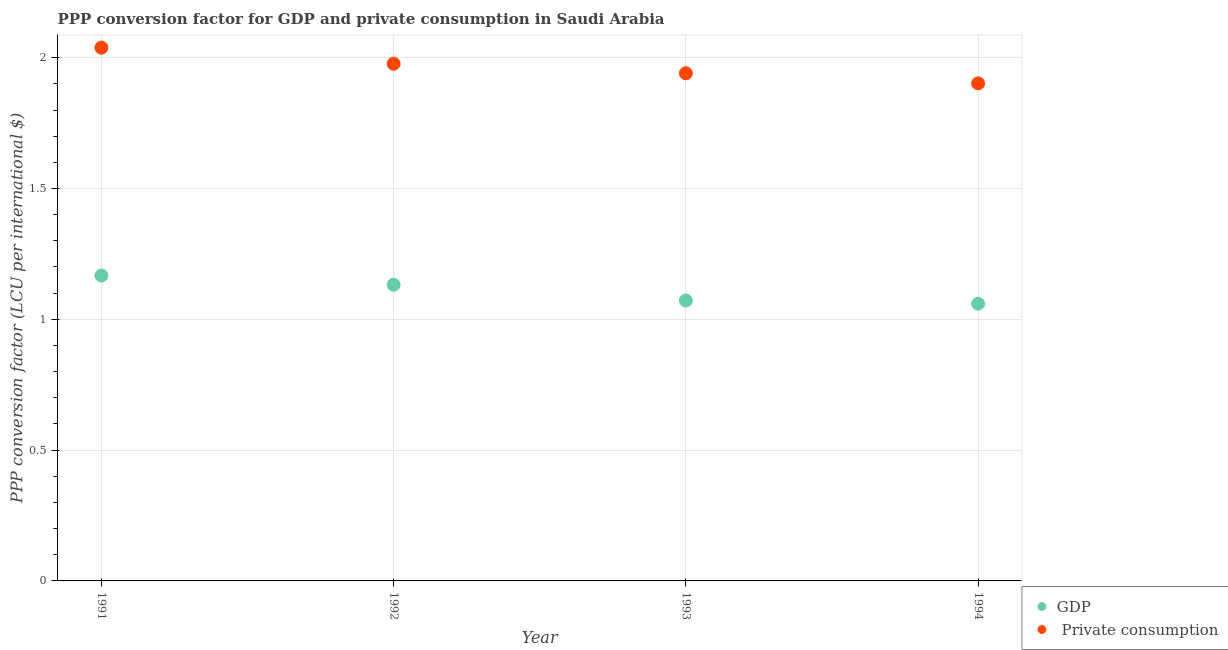What is the ppp conversion factor for gdp in 1993?
Provide a short and direct response. 1.07. Across all years, what is the maximum ppp conversion factor for gdp?
Give a very brief answer. 1.17. Across all years, what is the minimum ppp conversion factor for gdp?
Provide a succinct answer. 1.06. In which year was the ppp conversion factor for gdp maximum?
Ensure brevity in your answer.  1991. In which year was the ppp conversion factor for gdp minimum?
Your response must be concise. 1994. What is the total ppp conversion factor for private consumption in the graph?
Ensure brevity in your answer.  7.86. What is the difference between the ppp conversion factor for private consumption in 1991 and that in 1992?
Make the answer very short. 0.06. What is the difference between the ppp conversion factor for private consumption in 1993 and the ppp conversion factor for gdp in 1991?
Give a very brief answer. 0.77. What is the average ppp conversion factor for gdp per year?
Provide a short and direct response. 1.11. In the year 1994, what is the difference between the ppp conversion factor for gdp and ppp conversion factor for private consumption?
Your answer should be very brief. -0.84. In how many years, is the ppp conversion factor for gdp greater than 0.2 LCU?
Provide a succinct answer. 4. What is the ratio of the ppp conversion factor for private consumption in 1992 to that in 1994?
Make the answer very short. 1.04. What is the difference between the highest and the second highest ppp conversion factor for private consumption?
Give a very brief answer. 0.06. What is the difference between the highest and the lowest ppp conversion factor for private consumption?
Your answer should be very brief. 0.14. Is the sum of the ppp conversion factor for gdp in 1993 and 1994 greater than the maximum ppp conversion factor for private consumption across all years?
Your answer should be very brief. Yes. Does the ppp conversion factor for private consumption monotonically increase over the years?
Offer a very short reply. No. How many dotlines are there?
Your response must be concise. 2. What is the difference between two consecutive major ticks on the Y-axis?
Your answer should be very brief. 0.5. Are the values on the major ticks of Y-axis written in scientific E-notation?
Offer a terse response. No. Does the graph contain any zero values?
Your response must be concise. No. Where does the legend appear in the graph?
Keep it short and to the point. Bottom right. How are the legend labels stacked?
Ensure brevity in your answer.  Vertical. What is the title of the graph?
Provide a succinct answer. PPP conversion factor for GDP and private consumption in Saudi Arabia. Does "Frequency of shipment arrival" appear as one of the legend labels in the graph?
Offer a terse response. No. What is the label or title of the X-axis?
Ensure brevity in your answer.  Year. What is the label or title of the Y-axis?
Provide a short and direct response. PPP conversion factor (LCU per international $). What is the PPP conversion factor (LCU per international $) in GDP in 1991?
Provide a succinct answer. 1.17. What is the PPP conversion factor (LCU per international $) in  Private consumption in 1991?
Provide a short and direct response. 2.04. What is the PPP conversion factor (LCU per international $) of GDP in 1992?
Provide a short and direct response. 1.13. What is the PPP conversion factor (LCU per international $) in  Private consumption in 1992?
Provide a succinct answer. 1.98. What is the PPP conversion factor (LCU per international $) in GDP in 1993?
Your answer should be very brief. 1.07. What is the PPP conversion factor (LCU per international $) in  Private consumption in 1993?
Your answer should be very brief. 1.94. What is the PPP conversion factor (LCU per international $) of GDP in 1994?
Your response must be concise. 1.06. What is the PPP conversion factor (LCU per international $) of  Private consumption in 1994?
Provide a short and direct response. 1.9. Across all years, what is the maximum PPP conversion factor (LCU per international $) in GDP?
Your answer should be compact. 1.17. Across all years, what is the maximum PPP conversion factor (LCU per international $) of  Private consumption?
Your response must be concise. 2.04. Across all years, what is the minimum PPP conversion factor (LCU per international $) of GDP?
Provide a succinct answer. 1.06. Across all years, what is the minimum PPP conversion factor (LCU per international $) in  Private consumption?
Give a very brief answer. 1.9. What is the total PPP conversion factor (LCU per international $) in GDP in the graph?
Offer a terse response. 4.43. What is the total PPP conversion factor (LCU per international $) in  Private consumption in the graph?
Give a very brief answer. 7.86. What is the difference between the PPP conversion factor (LCU per international $) in GDP in 1991 and that in 1992?
Make the answer very short. 0.04. What is the difference between the PPP conversion factor (LCU per international $) of  Private consumption in 1991 and that in 1992?
Offer a very short reply. 0.06. What is the difference between the PPP conversion factor (LCU per international $) of GDP in 1991 and that in 1993?
Your response must be concise. 0.1. What is the difference between the PPP conversion factor (LCU per international $) in  Private consumption in 1991 and that in 1993?
Your answer should be compact. 0.1. What is the difference between the PPP conversion factor (LCU per international $) in GDP in 1991 and that in 1994?
Your answer should be compact. 0.11. What is the difference between the PPP conversion factor (LCU per international $) in  Private consumption in 1991 and that in 1994?
Provide a succinct answer. 0.14. What is the difference between the PPP conversion factor (LCU per international $) of GDP in 1992 and that in 1993?
Your answer should be compact. 0.06. What is the difference between the PPP conversion factor (LCU per international $) of  Private consumption in 1992 and that in 1993?
Provide a succinct answer. 0.04. What is the difference between the PPP conversion factor (LCU per international $) of GDP in 1992 and that in 1994?
Your answer should be compact. 0.07. What is the difference between the PPP conversion factor (LCU per international $) in  Private consumption in 1992 and that in 1994?
Your answer should be very brief. 0.07. What is the difference between the PPP conversion factor (LCU per international $) of GDP in 1993 and that in 1994?
Your answer should be compact. 0.01. What is the difference between the PPP conversion factor (LCU per international $) of  Private consumption in 1993 and that in 1994?
Your answer should be compact. 0.04. What is the difference between the PPP conversion factor (LCU per international $) in GDP in 1991 and the PPP conversion factor (LCU per international $) in  Private consumption in 1992?
Your response must be concise. -0.81. What is the difference between the PPP conversion factor (LCU per international $) of GDP in 1991 and the PPP conversion factor (LCU per international $) of  Private consumption in 1993?
Give a very brief answer. -0.77. What is the difference between the PPP conversion factor (LCU per international $) of GDP in 1991 and the PPP conversion factor (LCU per international $) of  Private consumption in 1994?
Ensure brevity in your answer.  -0.73. What is the difference between the PPP conversion factor (LCU per international $) of GDP in 1992 and the PPP conversion factor (LCU per international $) of  Private consumption in 1993?
Give a very brief answer. -0.81. What is the difference between the PPP conversion factor (LCU per international $) of GDP in 1992 and the PPP conversion factor (LCU per international $) of  Private consumption in 1994?
Make the answer very short. -0.77. What is the difference between the PPP conversion factor (LCU per international $) in GDP in 1993 and the PPP conversion factor (LCU per international $) in  Private consumption in 1994?
Make the answer very short. -0.83. What is the average PPP conversion factor (LCU per international $) in GDP per year?
Give a very brief answer. 1.11. What is the average PPP conversion factor (LCU per international $) in  Private consumption per year?
Your answer should be very brief. 1.96. In the year 1991, what is the difference between the PPP conversion factor (LCU per international $) in GDP and PPP conversion factor (LCU per international $) in  Private consumption?
Keep it short and to the point. -0.87. In the year 1992, what is the difference between the PPP conversion factor (LCU per international $) in GDP and PPP conversion factor (LCU per international $) in  Private consumption?
Provide a short and direct response. -0.84. In the year 1993, what is the difference between the PPP conversion factor (LCU per international $) in GDP and PPP conversion factor (LCU per international $) in  Private consumption?
Offer a very short reply. -0.87. In the year 1994, what is the difference between the PPP conversion factor (LCU per international $) of GDP and PPP conversion factor (LCU per international $) of  Private consumption?
Give a very brief answer. -0.84. What is the ratio of the PPP conversion factor (LCU per international $) in GDP in 1991 to that in 1992?
Ensure brevity in your answer.  1.03. What is the ratio of the PPP conversion factor (LCU per international $) of  Private consumption in 1991 to that in 1992?
Keep it short and to the point. 1.03. What is the ratio of the PPP conversion factor (LCU per international $) in GDP in 1991 to that in 1993?
Your response must be concise. 1.09. What is the ratio of the PPP conversion factor (LCU per international $) in  Private consumption in 1991 to that in 1993?
Offer a terse response. 1.05. What is the ratio of the PPP conversion factor (LCU per international $) of GDP in 1991 to that in 1994?
Your answer should be compact. 1.1. What is the ratio of the PPP conversion factor (LCU per international $) in  Private consumption in 1991 to that in 1994?
Provide a succinct answer. 1.07. What is the ratio of the PPP conversion factor (LCU per international $) in GDP in 1992 to that in 1993?
Provide a short and direct response. 1.06. What is the ratio of the PPP conversion factor (LCU per international $) of  Private consumption in 1992 to that in 1993?
Your answer should be compact. 1.02. What is the ratio of the PPP conversion factor (LCU per international $) in GDP in 1992 to that in 1994?
Your response must be concise. 1.07. What is the ratio of the PPP conversion factor (LCU per international $) of  Private consumption in 1992 to that in 1994?
Ensure brevity in your answer.  1.04. What is the ratio of the PPP conversion factor (LCU per international $) of GDP in 1993 to that in 1994?
Ensure brevity in your answer.  1.01. What is the ratio of the PPP conversion factor (LCU per international $) in  Private consumption in 1993 to that in 1994?
Your answer should be very brief. 1.02. What is the difference between the highest and the second highest PPP conversion factor (LCU per international $) of GDP?
Ensure brevity in your answer.  0.04. What is the difference between the highest and the second highest PPP conversion factor (LCU per international $) of  Private consumption?
Provide a succinct answer. 0.06. What is the difference between the highest and the lowest PPP conversion factor (LCU per international $) in GDP?
Give a very brief answer. 0.11. What is the difference between the highest and the lowest PPP conversion factor (LCU per international $) of  Private consumption?
Your answer should be compact. 0.14. 